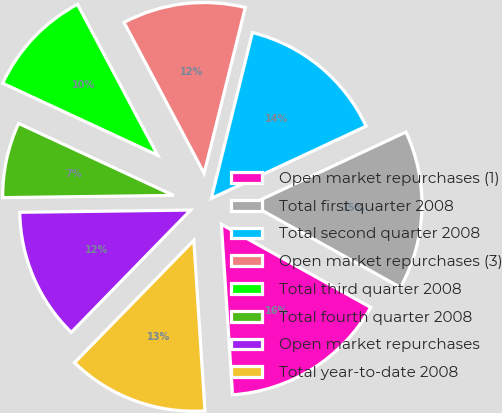Convert chart. <chart><loc_0><loc_0><loc_500><loc_500><pie_chart><fcel>Open market repurchases (1)<fcel>Total first quarter 2008<fcel>Total second quarter 2008<fcel>Open market repurchases (3)<fcel>Total third quarter 2008<fcel>Total fourth quarter 2008<fcel>Open market repurchases<fcel>Total year-to-date 2008<nl><fcel>15.88%<fcel>15.03%<fcel>14.18%<fcel>11.64%<fcel>10.31%<fcel>7.13%<fcel>12.49%<fcel>13.34%<nl></chart> 